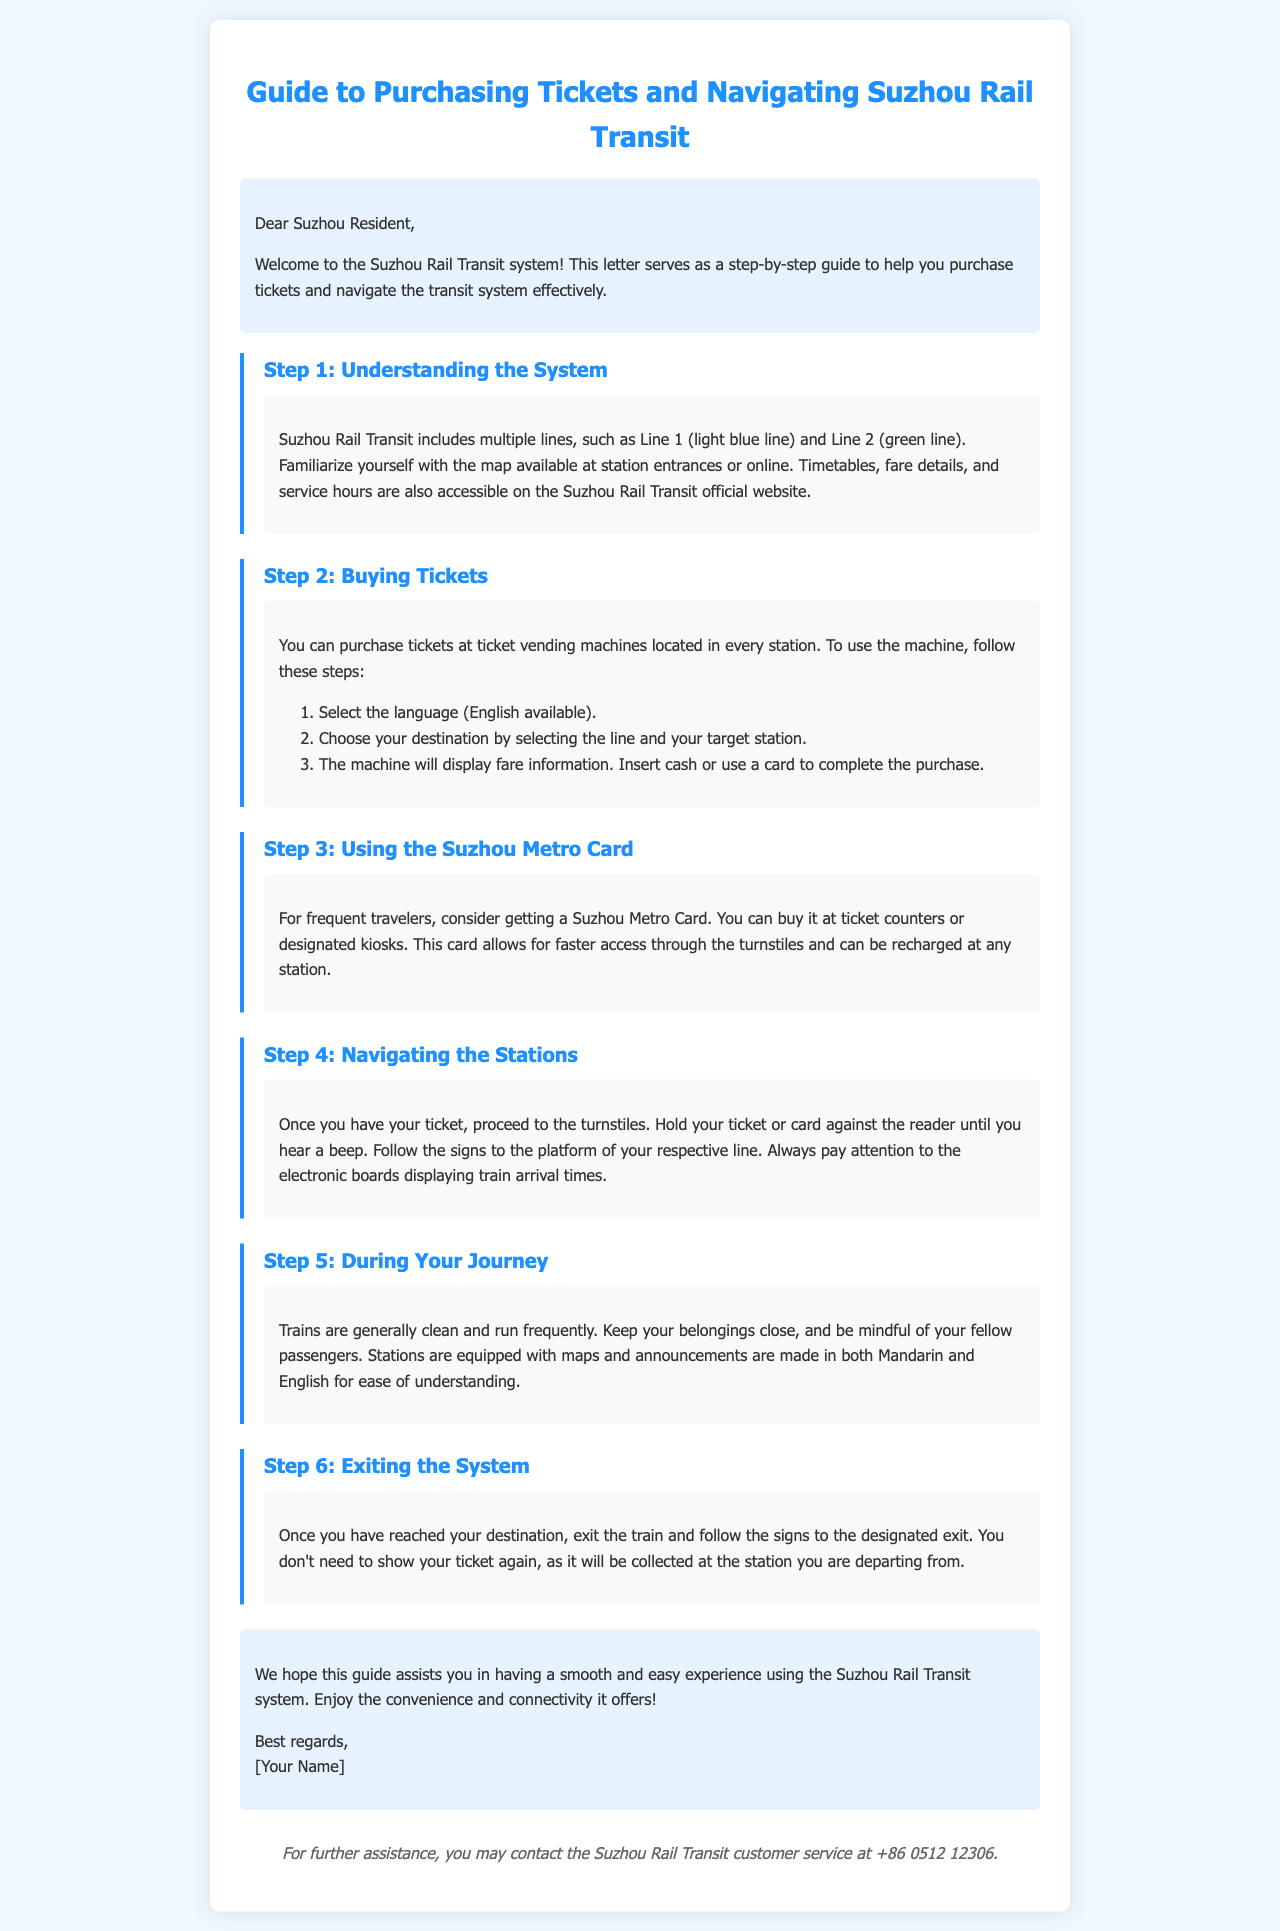What is the color of Line 1? Line 1 is described as the light blue line in the document.
Answer: light blue Where can you purchase a Suzhou Metro Card? The document states that you can buy a Suzhou Metro Card at ticket counters or designated kiosks.
Answer: ticket counters or designated kiosks What should you check before boarding the train? The document advises to pay attention to the electronic boards displaying train arrival times before boarding.
Answer: electronic boards How many steps are mentioned in the guide? The letter includes six steps for using the Suzhou Rail Transit system effectively.
Answer: six steps What is the contact number for customer service? The document provides the customer service contact number as +86 0512 12306.
Answer: +86 0512 12306 What language options are available at ticket vending machines? The guide mentions that English is available as a language option at the machines.
Answer: English What should you do if you want to exit the system? Upon reaching your destination, you should follow the signs to the designated exit according to the document.
Answer: follow the signs to the designated exit What is advised for keeping belongings during the journey? The document advises to keep your belongings close while on the train.
Answer: keep your belongings close 